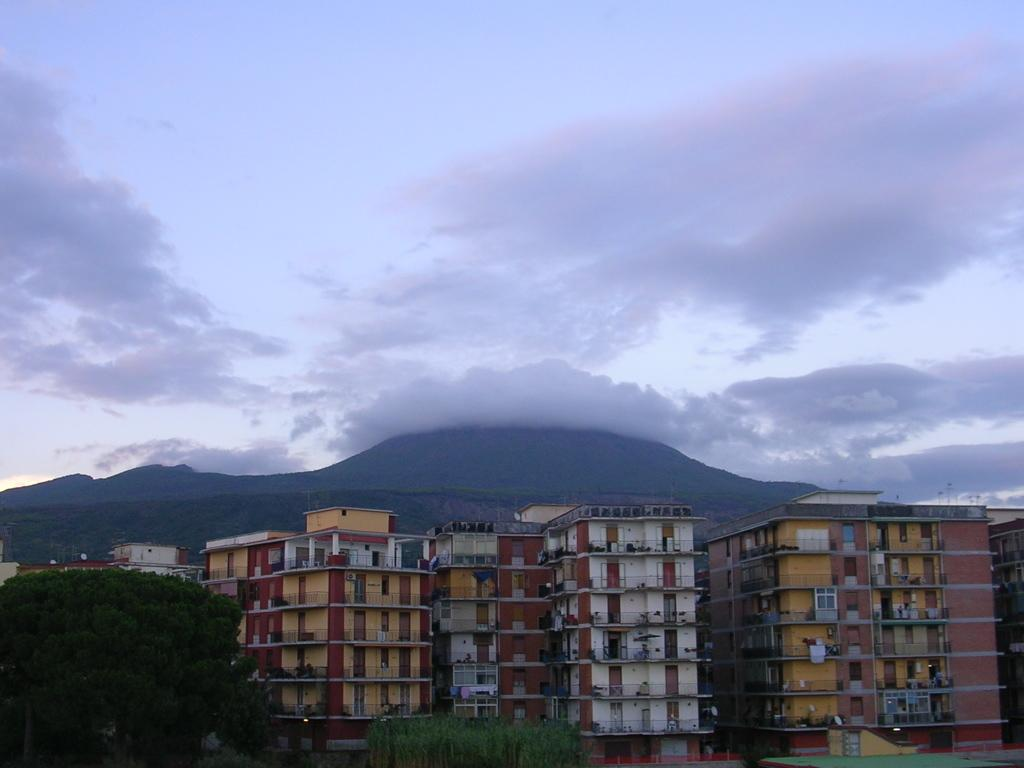What can be seen in the foreground of the image? There are trees and buildings in the foreground of the image. What is visible in the background of the image? Mountains and the sky are visible in the background of the image. Where is the wrench located in the image? There is no wrench present in the image. Can you tell me how many family members are visible in the image? There is no family depicted in the image. 